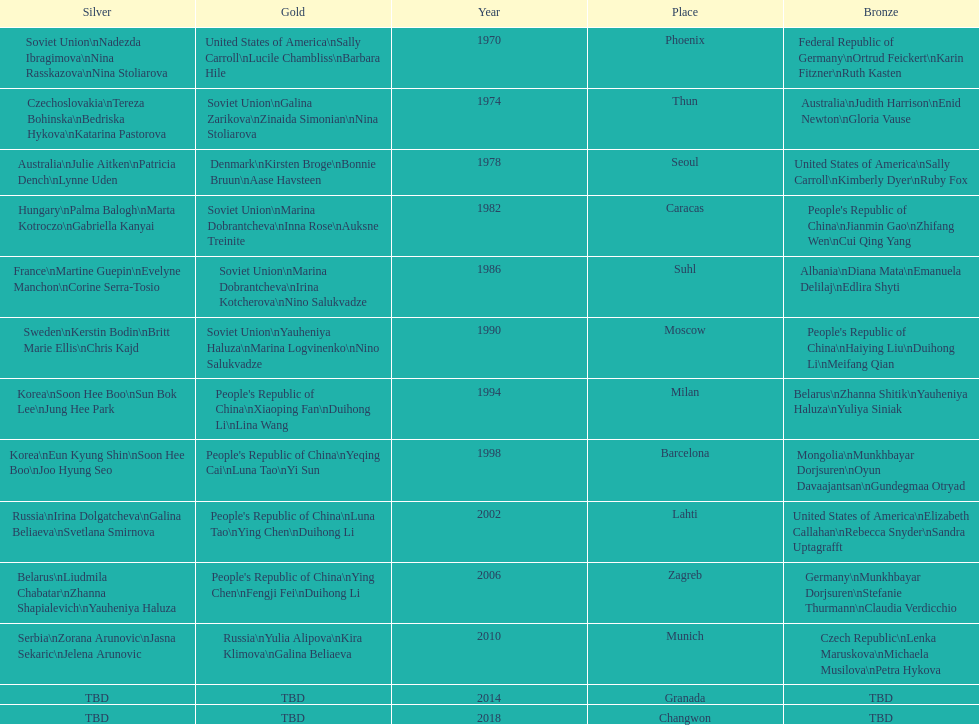Which country is most often mentioned in the silver column? Korea. 